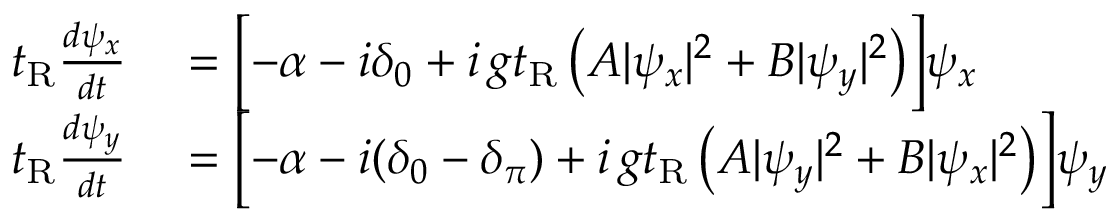<formula> <loc_0><loc_0><loc_500><loc_500>\begin{array} { r l } { t _ { R } \frac { d \psi _ { x } } { d t } } & = \left [ - \alpha - i \delta _ { 0 } + i \, g t _ { R } \left ( A | \psi _ { x } | ^ { 2 } + B | \psi _ { y } | ^ { 2 } \right ) \right ] \psi _ { x } } \\ { t _ { R } \frac { d \psi _ { y } } { d t } } & = \left [ - \alpha - i ( \delta _ { 0 } - \delta _ { \pi } ) + i \, g t _ { R } \left ( A | \psi _ { y } | ^ { 2 } + B | \psi _ { x } | ^ { 2 } \right ) \right ] \psi _ { y } } \end{array}</formula> 